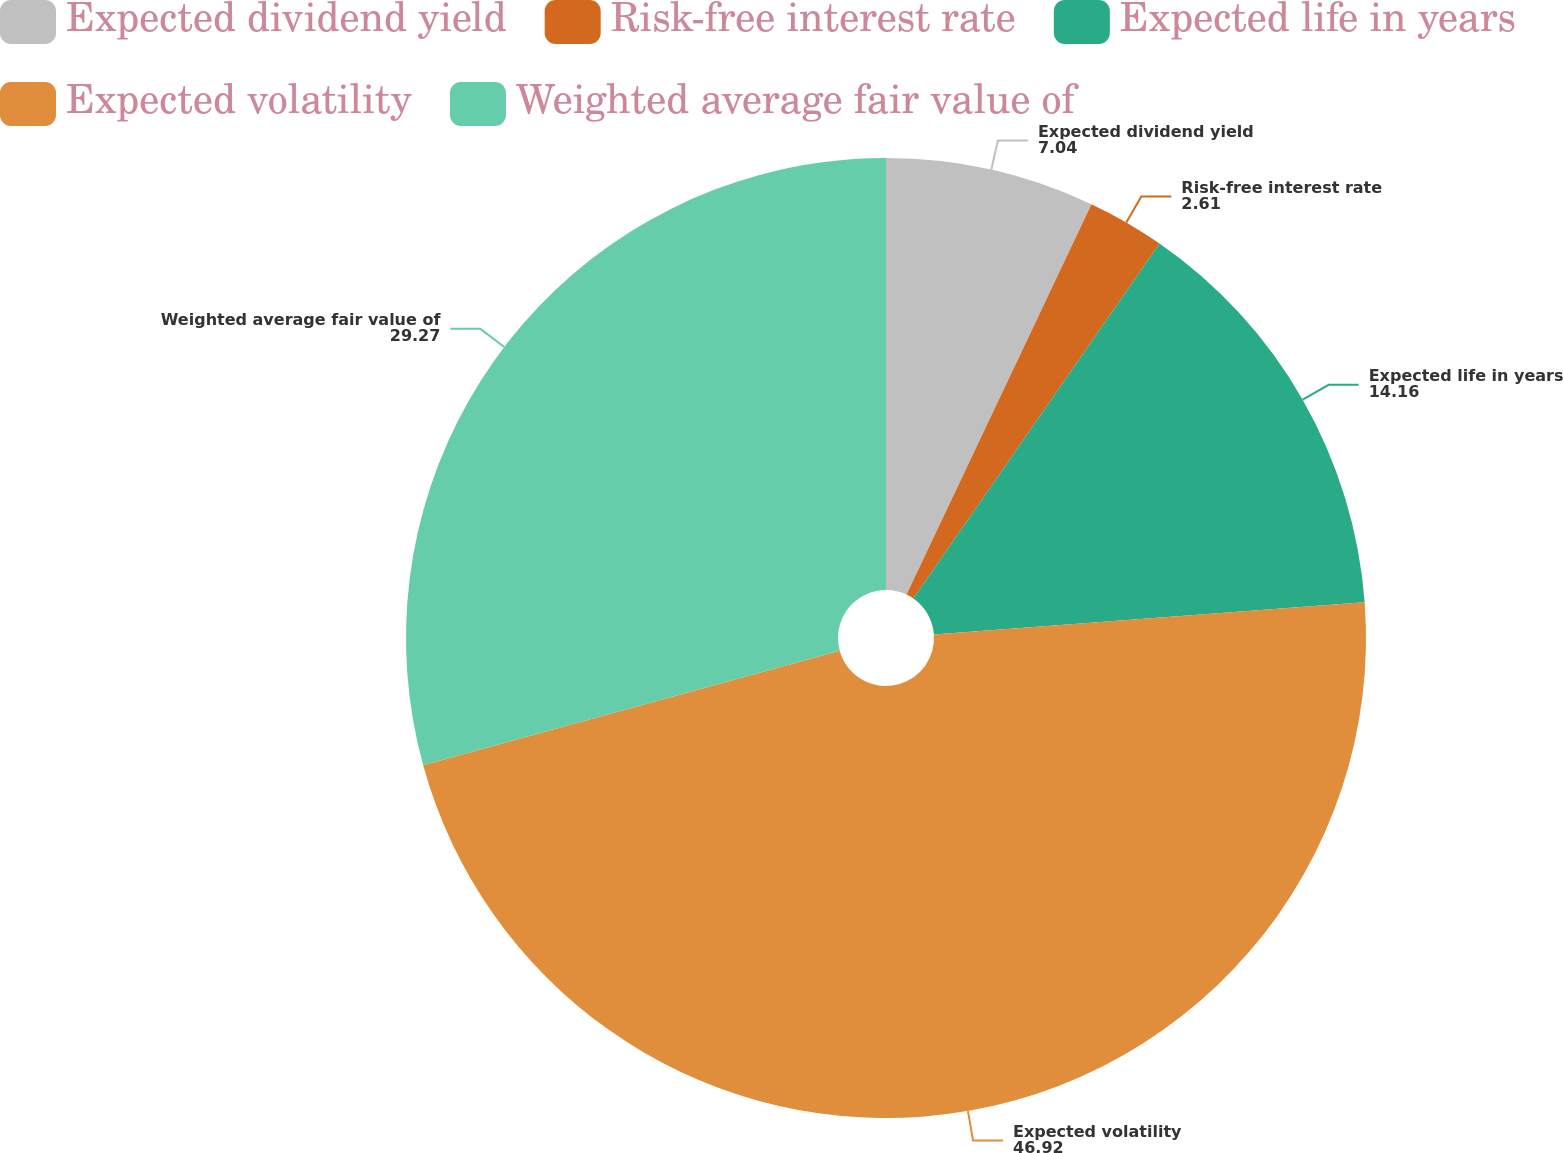Convert chart to OTSL. <chart><loc_0><loc_0><loc_500><loc_500><pie_chart><fcel>Expected dividend yield<fcel>Risk-free interest rate<fcel>Expected life in years<fcel>Expected volatility<fcel>Weighted average fair value of<nl><fcel>7.04%<fcel>2.61%<fcel>14.16%<fcel>46.92%<fcel>29.27%<nl></chart> 